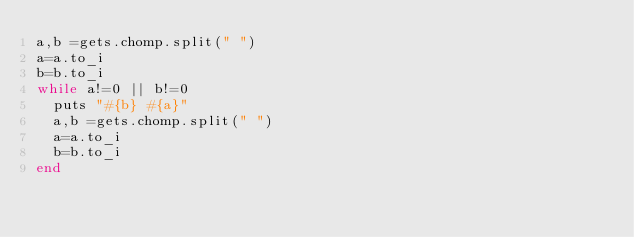<code> <loc_0><loc_0><loc_500><loc_500><_Ruby_>a,b =gets.chomp.split(" ")
a=a.to_i
b=b.to_i
while a!=0 || b!=0
	puts "#{b} #{a}"
	a,b =gets.chomp.split(" ")
	a=a.to_i
	b=b.to_i
end</code> 